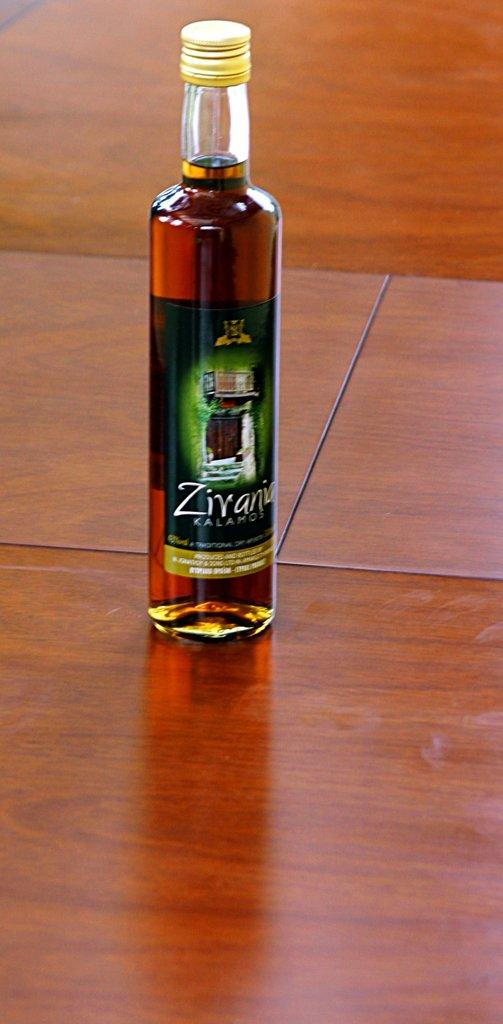What is the main object in the image? There is a wine bottle in the image. What can be seen on the wine bottle? The wine bottle has a label and a lid. Where is the wine bottle located? The wine bottle is placed on a table. What type of gun is present in the image? There is no gun present in the image; it only features a wine bottle with a label and lid on a table. 